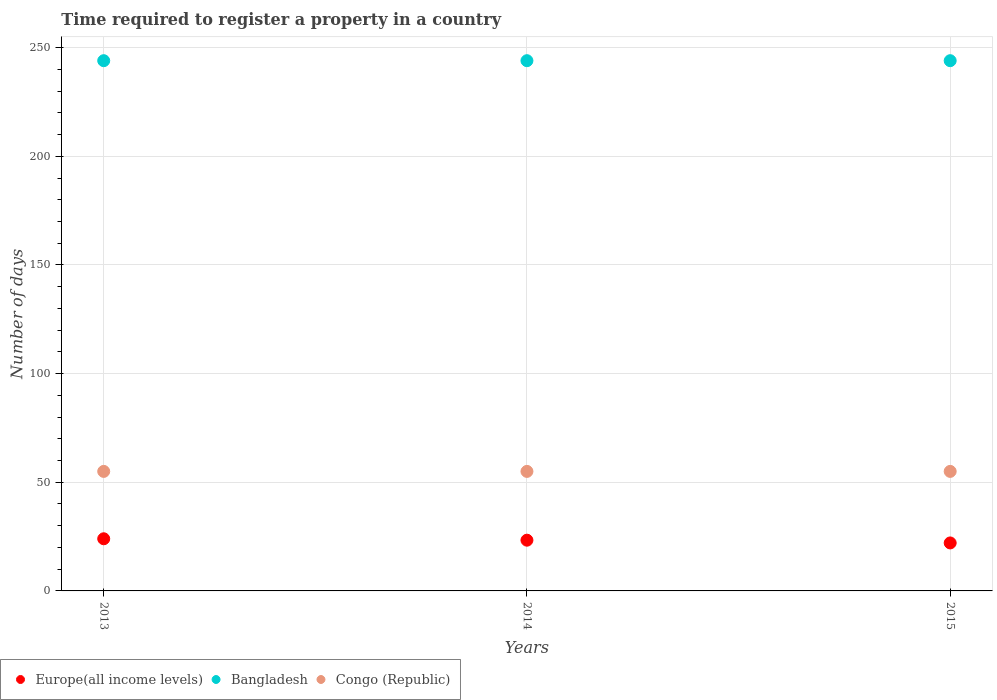What is the number of days required to register a property in Bangladesh in 2014?
Provide a succinct answer. 244. Across all years, what is the maximum number of days required to register a property in Bangladesh?
Make the answer very short. 244. Across all years, what is the minimum number of days required to register a property in Bangladesh?
Ensure brevity in your answer.  244. In which year was the number of days required to register a property in Congo (Republic) minimum?
Offer a very short reply. 2013. What is the total number of days required to register a property in Congo (Republic) in the graph?
Offer a very short reply. 165. What is the difference between the number of days required to register a property in Europe(all income levels) in 2013 and that in 2015?
Ensure brevity in your answer.  1.92. What is the difference between the number of days required to register a property in Europe(all income levels) in 2015 and the number of days required to register a property in Bangladesh in 2014?
Make the answer very short. -221.92. What is the average number of days required to register a property in Europe(all income levels) per year?
Your answer should be compact. 23.14. In the year 2014, what is the difference between the number of days required to register a property in Bangladesh and number of days required to register a property in Congo (Republic)?
Give a very brief answer. 189. What is the ratio of the number of days required to register a property in Bangladesh in 2014 to that in 2015?
Keep it short and to the point. 1. Is the number of days required to register a property in Europe(all income levels) in 2013 less than that in 2014?
Ensure brevity in your answer.  No. Is the difference between the number of days required to register a property in Bangladesh in 2014 and 2015 greater than the difference between the number of days required to register a property in Congo (Republic) in 2014 and 2015?
Ensure brevity in your answer.  No. What is the difference between the highest and the lowest number of days required to register a property in Europe(all income levels)?
Offer a terse response. 1.92. Is it the case that in every year, the sum of the number of days required to register a property in Europe(all income levels) and number of days required to register a property in Congo (Republic)  is greater than the number of days required to register a property in Bangladesh?
Provide a succinct answer. No. Does the number of days required to register a property in Bangladesh monotonically increase over the years?
Ensure brevity in your answer.  No. What is the difference between two consecutive major ticks on the Y-axis?
Keep it short and to the point. 50. Does the graph contain any zero values?
Your answer should be very brief. No. What is the title of the graph?
Provide a succinct answer. Time required to register a property in a country. Does "Egypt, Arab Rep." appear as one of the legend labels in the graph?
Provide a succinct answer. No. What is the label or title of the Y-axis?
Make the answer very short. Number of days. What is the Number of days in Europe(all income levels) in 2013?
Your answer should be compact. 24. What is the Number of days in Bangladesh in 2013?
Your answer should be compact. 244. What is the Number of days of Europe(all income levels) in 2014?
Provide a succinct answer. 23.35. What is the Number of days of Bangladesh in 2014?
Your response must be concise. 244. What is the Number of days in Congo (Republic) in 2014?
Offer a very short reply. 55. What is the Number of days of Europe(all income levels) in 2015?
Your answer should be very brief. 22.08. What is the Number of days in Bangladesh in 2015?
Your response must be concise. 244. Across all years, what is the maximum Number of days in Europe(all income levels)?
Your answer should be compact. 24. Across all years, what is the maximum Number of days in Bangladesh?
Offer a terse response. 244. Across all years, what is the maximum Number of days of Congo (Republic)?
Your answer should be very brief. 55. Across all years, what is the minimum Number of days of Europe(all income levels)?
Provide a succinct answer. 22.08. Across all years, what is the minimum Number of days of Bangladesh?
Your response must be concise. 244. Across all years, what is the minimum Number of days of Congo (Republic)?
Provide a succinct answer. 55. What is the total Number of days of Europe(all income levels) in the graph?
Give a very brief answer. 69.43. What is the total Number of days in Bangladesh in the graph?
Offer a very short reply. 732. What is the total Number of days of Congo (Republic) in the graph?
Give a very brief answer. 165. What is the difference between the Number of days of Europe(all income levels) in 2013 and that in 2014?
Make the answer very short. 0.65. What is the difference between the Number of days in Congo (Republic) in 2013 and that in 2014?
Your response must be concise. 0. What is the difference between the Number of days in Europe(all income levels) in 2013 and that in 2015?
Provide a succinct answer. 1.92. What is the difference between the Number of days of Bangladesh in 2013 and that in 2015?
Keep it short and to the point. 0. What is the difference between the Number of days of Europe(all income levels) in 2014 and that in 2015?
Make the answer very short. 1.27. What is the difference between the Number of days in Bangladesh in 2014 and that in 2015?
Provide a succinct answer. 0. What is the difference between the Number of days in Congo (Republic) in 2014 and that in 2015?
Your answer should be very brief. 0. What is the difference between the Number of days in Europe(all income levels) in 2013 and the Number of days in Bangladesh in 2014?
Offer a terse response. -220. What is the difference between the Number of days of Europe(all income levels) in 2013 and the Number of days of Congo (Republic) in 2014?
Your answer should be compact. -31. What is the difference between the Number of days in Bangladesh in 2013 and the Number of days in Congo (Republic) in 2014?
Ensure brevity in your answer.  189. What is the difference between the Number of days in Europe(all income levels) in 2013 and the Number of days in Bangladesh in 2015?
Your answer should be compact. -220. What is the difference between the Number of days of Europe(all income levels) in 2013 and the Number of days of Congo (Republic) in 2015?
Your answer should be very brief. -31. What is the difference between the Number of days of Bangladesh in 2013 and the Number of days of Congo (Republic) in 2015?
Provide a short and direct response. 189. What is the difference between the Number of days of Europe(all income levels) in 2014 and the Number of days of Bangladesh in 2015?
Provide a short and direct response. -220.65. What is the difference between the Number of days of Europe(all income levels) in 2014 and the Number of days of Congo (Republic) in 2015?
Your response must be concise. -31.65. What is the difference between the Number of days in Bangladesh in 2014 and the Number of days in Congo (Republic) in 2015?
Your response must be concise. 189. What is the average Number of days in Europe(all income levels) per year?
Your response must be concise. 23.14. What is the average Number of days of Bangladesh per year?
Your answer should be compact. 244. In the year 2013, what is the difference between the Number of days in Europe(all income levels) and Number of days in Bangladesh?
Give a very brief answer. -220. In the year 2013, what is the difference between the Number of days in Europe(all income levels) and Number of days in Congo (Republic)?
Your answer should be compact. -31. In the year 2013, what is the difference between the Number of days of Bangladesh and Number of days of Congo (Republic)?
Make the answer very short. 189. In the year 2014, what is the difference between the Number of days of Europe(all income levels) and Number of days of Bangladesh?
Your response must be concise. -220.65. In the year 2014, what is the difference between the Number of days in Europe(all income levels) and Number of days in Congo (Republic)?
Provide a succinct answer. -31.65. In the year 2014, what is the difference between the Number of days in Bangladesh and Number of days in Congo (Republic)?
Your response must be concise. 189. In the year 2015, what is the difference between the Number of days of Europe(all income levels) and Number of days of Bangladesh?
Keep it short and to the point. -221.92. In the year 2015, what is the difference between the Number of days in Europe(all income levels) and Number of days in Congo (Republic)?
Your response must be concise. -32.92. In the year 2015, what is the difference between the Number of days in Bangladesh and Number of days in Congo (Republic)?
Provide a short and direct response. 189. What is the ratio of the Number of days of Europe(all income levels) in 2013 to that in 2014?
Ensure brevity in your answer.  1.03. What is the ratio of the Number of days in Bangladesh in 2013 to that in 2014?
Your response must be concise. 1. What is the ratio of the Number of days in Europe(all income levels) in 2013 to that in 2015?
Offer a very short reply. 1.09. What is the ratio of the Number of days in Bangladesh in 2013 to that in 2015?
Your answer should be compact. 1. What is the ratio of the Number of days of Europe(all income levels) in 2014 to that in 2015?
Provide a succinct answer. 1.06. What is the difference between the highest and the second highest Number of days of Europe(all income levels)?
Ensure brevity in your answer.  0.65. What is the difference between the highest and the second highest Number of days of Congo (Republic)?
Your answer should be very brief. 0. What is the difference between the highest and the lowest Number of days of Europe(all income levels)?
Keep it short and to the point. 1.92. What is the difference between the highest and the lowest Number of days in Bangladesh?
Provide a short and direct response. 0. What is the difference between the highest and the lowest Number of days of Congo (Republic)?
Provide a succinct answer. 0. 